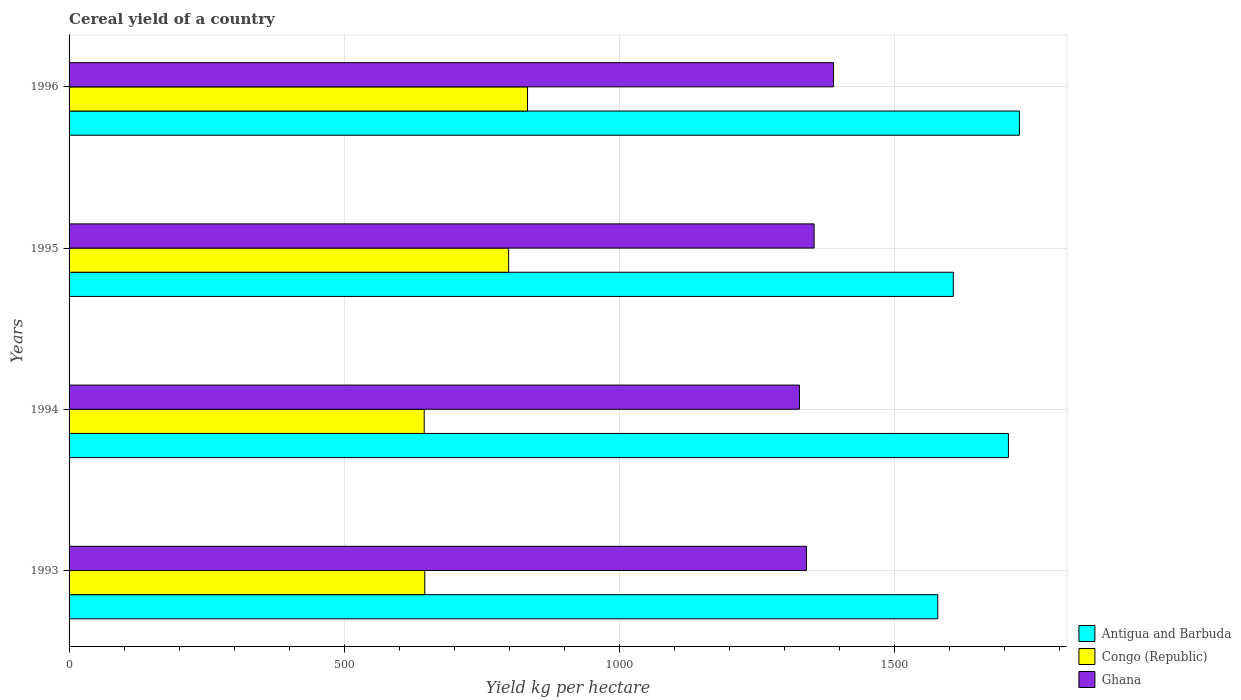How many different coloured bars are there?
Provide a succinct answer. 3. How many bars are there on the 2nd tick from the bottom?
Your response must be concise. 3. What is the label of the 3rd group of bars from the top?
Provide a short and direct response. 1994. What is the total cereal yield in Congo (Republic) in 1995?
Offer a very short reply. 798.93. Across all years, what is the maximum total cereal yield in Congo (Republic)?
Provide a short and direct response. 833.29. Across all years, what is the minimum total cereal yield in Ghana?
Keep it short and to the point. 1327.49. What is the total total cereal yield in Congo (Republic) in the graph?
Keep it short and to the point. 2924.2. What is the difference between the total cereal yield in Congo (Republic) in 1995 and that in 1996?
Provide a short and direct response. -34.35. What is the difference between the total cereal yield in Congo (Republic) in 1993 and the total cereal yield in Antigua and Barbuda in 1996?
Give a very brief answer. -1080.78. What is the average total cereal yield in Congo (Republic) per year?
Offer a very short reply. 731.05. In the year 1993, what is the difference between the total cereal yield in Ghana and total cereal yield in Antigua and Barbuda?
Make the answer very short. -238.74. In how many years, is the total cereal yield in Antigua and Barbuda greater than 100 kg per hectare?
Your response must be concise. 4. What is the ratio of the total cereal yield in Antigua and Barbuda in 1994 to that in 1996?
Your answer should be very brief. 0.99. Is the total cereal yield in Antigua and Barbuda in 1995 less than that in 1996?
Your answer should be compact. Yes. What is the difference between the highest and the second highest total cereal yield in Ghana?
Ensure brevity in your answer.  35.12. What is the difference between the highest and the lowest total cereal yield in Ghana?
Make the answer very short. 61.75. Is the sum of the total cereal yield in Congo (Republic) in 1994 and 1995 greater than the maximum total cereal yield in Antigua and Barbuda across all years?
Make the answer very short. No. What does the 1st bar from the top in 1993 represents?
Your answer should be very brief. Ghana. What does the 2nd bar from the bottom in 1994 represents?
Offer a very short reply. Congo (Republic). Are the values on the major ticks of X-axis written in scientific E-notation?
Ensure brevity in your answer.  No. Does the graph contain grids?
Ensure brevity in your answer.  Yes. How are the legend labels stacked?
Provide a short and direct response. Vertical. What is the title of the graph?
Offer a very short reply. Cereal yield of a country. What is the label or title of the X-axis?
Your answer should be very brief. Yield kg per hectare. What is the label or title of the Y-axis?
Keep it short and to the point. Years. What is the Yield kg per hectare of Antigua and Barbuda in 1993?
Your response must be concise. 1578.95. What is the Yield kg per hectare of Congo (Republic) in 1993?
Offer a very short reply. 646.49. What is the Yield kg per hectare in Ghana in 1993?
Ensure brevity in your answer.  1340.2. What is the Yield kg per hectare of Antigua and Barbuda in 1994?
Your answer should be very brief. 1707.32. What is the Yield kg per hectare in Congo (Republic) in 1994?
Keep it short and to the point. 645.48. What is the Yield kg per hectare in Ghana in 1994?
Keep it short and to the point. 1327.49. What is the Yield kg per hectare of Antigua and Barbuda in 1995?
Give a very brief answer. 1607.14. What is the Yield kg per hectare in Congo (Republic) in 1995?
Your answer should be compact. 798.93. What is the Yield kg per hectare of Ghana in 1995?
Provide a short and direct response. 1354.12. What is the Yield kg per hectare of Antigua and Barbuda in 1996?
Your answer should be compact. 1727.27. What is the Yield kg per hectare of Congo (Republic) in 1996?
Provide a short and direct response. 833.29. What is the Yield kg per hectare in Ghana in 1996?
Provide a short and direct response. 1389.24. Across all years, what is the maximum Yield kg per hectare of Antigua and Barbuda?
Offer a very short reply. 1727.27. Across all years, what is the maximum Yield kg per hectare in Congo (Republic)?
Make the answer very short. 833.29. Across all years, what is the maximum Yield kg per hectare of Ghana?
Provide a succinct answer. 1389.24. Across all years, what is the minimum Yield kg per hectare in Antigua and Barbuda?
Offer a terse response. 1578.95. Across all years, what is the minimum Yield kg per hectare in Congo (Republic)?
Your answer should be very brief. 645.48. Across all years, what is the minimum Yield kg per hectare in Ghana?
Your answer should be very brief. 1327.49. What is the total Yield kg per hectare of Antigua and Barbuda in the graph?
Ensure brevity in your answer.  6620.68. What is the total Yield kg per hectare in Congo (Republic) in the graph?
Your answer should be compact. 2924.2. What is the total Yield kg per hectare in Ghana in the graph?
Offer a very short reply. 5411.05. What is the difference between the Yield kg per hectare in Antigua and Barbuda in 1993 and that in 1994?
Provide a succinct answer. -128.37. What is the difference between the Yield kg per hectare in Ghana in 1993 and that in 1994?
Your response must be concise. 12.72. What is the difference between the Yield kg per hectare of Antigua and Barbuda in 1993 and that in 1995?
Your response must be concise. -28.2. What is the difference between the Yield kg per hectare of Congo (Republic) in 1993 and that in 1995?
Ensure brevity in your answer.  -152.44. What is the difference between the Yield kg per hectare in Ghana in 1993 and that in 1995?
Provide a short and direct response. -13.92. What is the difference between the Yield kg per hectare of Antigua and Barbuda in 1993 and that in 1996?
Offer a very short reply. -148.33. What is the difference between the Yield kg per hectare of Congo (Republic) in 1993 and that in 1996?
Provide a succinct answer. -186.8. What is the difference between the Yield kg per hectare in Ghana in 1993 and that in 1996?
Provide a succinct answer. -49.03. What is the difference between the Yield kg per hectare of Antigua and Barbuda in 1994 and that in 1995?
Give a very brief answer. 100.17. What is the difference between the Yield kg per hectare of Congo (Republic) in 1994 and that in 1995?
Provide a short and direct response. -153.46. What is the difference between the Yield kg per hectare of Ghana in 1994 and that in 1995?
Your response must be concise. -26.63. What is the difference between the Yield kg per hectare in Antigua and Barbuda in 1994 and that in 1996?
Provide a short and direct response. -19.96. What is the difference between the Yield kg per hectare in Congo (Republic) in 1994 and that in 1996?
Your answer should be compact. -187.81. What is the difference between the Yield kg per hectare in Ghana in 1994 and that in 1996?
Give a very brief answer. -61.75. What is the difference between the Yield kg per hectare in Antigua and Barbuda in 1995 and that in 1996?
Your answer should be very brief. -120.13. What is the difference between the Yield kg per hectare in Congo (Republic) in 1995 and that in 1996?
Provide a short and direct response. -34.35. What is the difference between the Yield kg per hectare in Ghana in 1995 and that in 1996?
Your response must be concise. -35.12. What is the difference between the Yield kg per hectare of Antigua and Barbuda in 1993 and the Yield kg per hectare of Congo (Republic) in 1994?
Make the answer very short. 933.47. What is the difference between the Yield kg per hectare of Antigua and Barbuda in 1993 and the Yield kg per hectare of Ghana in 1994?
Offer a very short reply. 251.46. What is the difference between the Yield kg per hectare in Congo (Republic) in 1993 and the Yield kg per hectare in Ghana in 1994?
Offer a terse response. -681. What is the difference between the Yield kg per hectare in Antigua and Barbuda in 1993 and the Yield kg per hectare in Congo (Republic) in 1995?
Ensure brevity in your answer.  780.01. What is the difference between the Yield kg per hectare in Antigua and Barbuda in 1993 and the Yield kg per hectare in Ghana in 1995?
Your answer should be compact. 224.82. What is the difference between the Yield kg per hectare in Congo (Republic) in 1993 and the Yield kg per hectare in Ghana in 1995?
Make the answer very short. -707.63. What is the difference between the Yield kg per hectare of Antigua and Barbuda in 1993 and the Yield kg per hectare of Congo (Republic) in 1996?
Provide a succinct answer. 745.66. What is the difference between the Yield kg per hectare of Antigua and Barbuda in 1993 and the Yield kg per hectare of Ghana in 1996?
Give a very brief answer. 189.71. What is the difference between the Yield kg per hectare in Congo (Republic) in 1993 and the Yield kg per hectare in Ghana in 1996?
Provide a short and direct response. -742.74. What is the difference between the Yield kg per hectare in Antigua and Barbuda in 1994 and the Yield kg per hectare in Congo (Republic) in 1995?
Offer a very short reply. 908.38. What is the difference between the Yield kg per hectare of Antigua and Barbuda in 1994 and the Yield kg per hectare of Ghana in 1995?
Offer a terse response. 353.19. What is the difference between the Yield kg per hectare of Congo (Republic) in 1994 and the Yield kg per hectare of Ghana in 1995?
Your answer should be very brief. -708.64. What is the difference between the Yield kg per hectare in Antigua and Barbuda in 1994 and the Yield kg per hectare in Congo (Republic) in 1996?
Your answer should be compact. 874.03. What is the difference between the Yield kg per hectare of Antigua and Barbuda in 1994 and the Yield kg per hectare of Ghana in 1996?
Offer a very short reply. 318.08. What is the difference between the Yield kg per hectare of Congo (Republic) in 1994 and the Yield kg per hectare of Ghana in 1996?
Your answer should be very brief. -743.76. What is the difference between the Yield kg per hectare in Antigua and Barbuda in 1995 and the Yield kg per hectare in Congo (Republic) in 1996?
Make the answer very short. 773.85. What is the difference between the Yield kg per hectare of Antigua and Barbuda in 1995 and the Yield kg per hectare of Ghana in 1996?
Offer a very short reply. 217.91. What is the difference between the Yield kg per hectare in Congo (Republic) in 1995 and the Yield kg per hectare in Ghana in 1996?
Your answer should be compact. -590.3. What is the average Yield kg per hectare in Antigua and Barbuda per year?
Offer a terse response. 1655.17. What is the average Yield kg per hectare of Congo (Republic) per year?
Keep it short and to the point. 731.05. What is the average Yield kg per hectare in Ghana per year?
Provide a short and direct response. 1352.76. In the year 1993, what is the difference between the Yield kg per hectare of Antigua and Barbuda and Yield kg per hectare of Congo (Republic)?
Ensure brevity in your answer.  932.45. In the year 1993, what is the difference between the Yield kg per hectare in Antigua and Barbuda and Yield kg per hectare in Ghana?
Provide a succinct answer. 238.74. In the year 1993, what is the difference between the Yield kg per hectare of Congo (Republic) and Yield kg per hectare of Ghana?
Ensure brevity in your answer.  -693.71. In the year 1994, what is the difference between the Yield kg per hectare of Antigua and Barbuda and Yield kg per hectare of Congo (Republic)?
Your answer should be compact. 1061.84. In the year 1994, what is the difference between the Yield kg per hectare in Antigua and Barbuda and Yield kg per hectare in Ghana?
Ensure brevity in your answer.  379.83. In the year 1994, what is the difference between the Yield kg per hectare in Congo (Republic) and Yield kg per hectare in Ghana?
Offer a very short reply. -682.01. In the year 1995, what is the difference between the Yield kg per hectare of Antigua and Barbuda and Yield kg per hectare of Congo (Republic)?
Provide a succinct answer. 808.21. In the year 1995, what is the difference between the Yield kg per hectare in Antigua and Barbuda and Yield kg per hectare in Ghana?
Your answer should be compact. 253.02. In the year 1995, what is the difference between the Yield kg per hectare of Congo (Republic) and Yield kg per hectare of Ghana?
Offer a very short reply. -555.19. In the year 1996, what is the difference between the Yield kg per hectare in Antigua and Barbuda and Yield kg per hectare in Congo (Republic)?
Give a very brief answer. 893.98. In the year 1996, what is the difference between the Yield kg per hectare in Antigua and Barbuda and Yield kg per hectare in Ghana?
Provide a succinct answer. 338.04. In the year 1996, what is the difference between the Yield kg per hectare in Congo (Republic) and Yield kg per hectare in Ghana?
Offer a terse response. -555.95. What is the ratio of the Yield kg per hectare in Antigua and Barbuda in 1993 to that in 1994?
Your response must be concise. 0.92. What is the ratio of the Yield kg per hectare in Congo (Republic) in 1993 to that in 1994?
Your response must be concise. 1. What is the ratio of the Yield kg per hectare in Ghana in 1993 to that in 1994?
Keep it short and to the point. 1.01. What is the ratio of the Yield kg per hectare in Antigua and Barbuda in 1993 to that in 1995?
Your response must be concise. 0.98. What is the ratio of the Yield kg per hectare in Congo (Republic) in 1993 to that in 1995?
Ensure brevity in your answer.  0.81. What is the ratio of the Yield kg per hectare of Antigua and Barbuda in 1993 to that in 1996?
Your answer should be compact. 0.91. What is the ratio of the Yield kg per hectare in Congo (Republic) in 1993 to that in 1996?
Give a very brief answer. 0.78. What is the ratio of the Yield kg per hectare of Ghana in 1993 to that in 1996?
Offer a very short reply. 0.96. What is the ratio of the Yield kg per hectare in Antigua and Barbuda in 1994 to that in 1995?
Ensure brevity in your answer.  1.06. What is the ratio of the Yield kg per hectare in Congo (Republic) in 1994 to that in 1995?
Provide a short and direct response. 0.81. What is the ratio of the Yield kg per hectare in Ghana in 1994 to that in 1995?
Make the answer very short. 0.98. What is the ratio of the Yield kg per hectare in Antigua and Barbuda in 1994 to that in 1996?
Make the answer very short. 0.99. What is the ratio of the Yield kg per hectare in Congo (Republic) in 1994 to that in 1996?
Your answer should be compact. 0.77. What is the ratio of the Yield kg per hectare in Ghana in 1994 to that in 1996?
Provide a short and direct response. 0.96. What is the ratio of the Yield kg per hectare in Antigua and Barbuda in 1995 to that in 1996?
Keep it short and to the point. 0.93. What is the ratio of the Yield kg per hectare in Congo (Republic) in 1995 to that in 1996?
Offer a very short reply. 0.96. What is the ratio of the Yield kg per hectare in Ghana in 1995 to that in 1996?
Give a very brief answer. 0.97. What is the difference between the highest and the second highest Yield kg per hectare in Antigua and Barbuda?
Give a very brief answer. 19.96. What is the difference between the highest and the second highest Yield kg per hectare in Congo (Republic)?
Your answer should be very brief. 34.35. What is the difference between the highest and the second highest Yield kg per hectare in Ghana?
Keep it short and to the point. 35.12. What is the difference between the highest and the lowest Yield kg per hectare in Antigua and Barbuda?
Your answer should be very brief. 148.33. What is the difference between the highest and the lowest Yield kg per hectare of Congo (Republic)?
Offer a very short reply. 187.81. What is the difference between the highest and the lowest Yield kg per hectare of Ghana?
Ensure brevity in your answer.  61.75. 